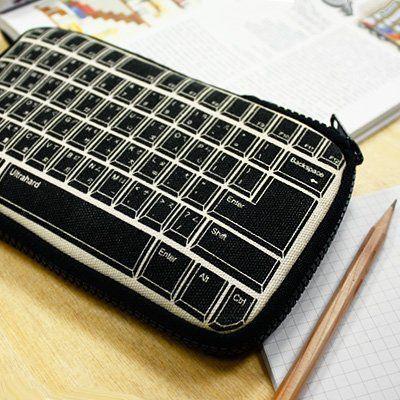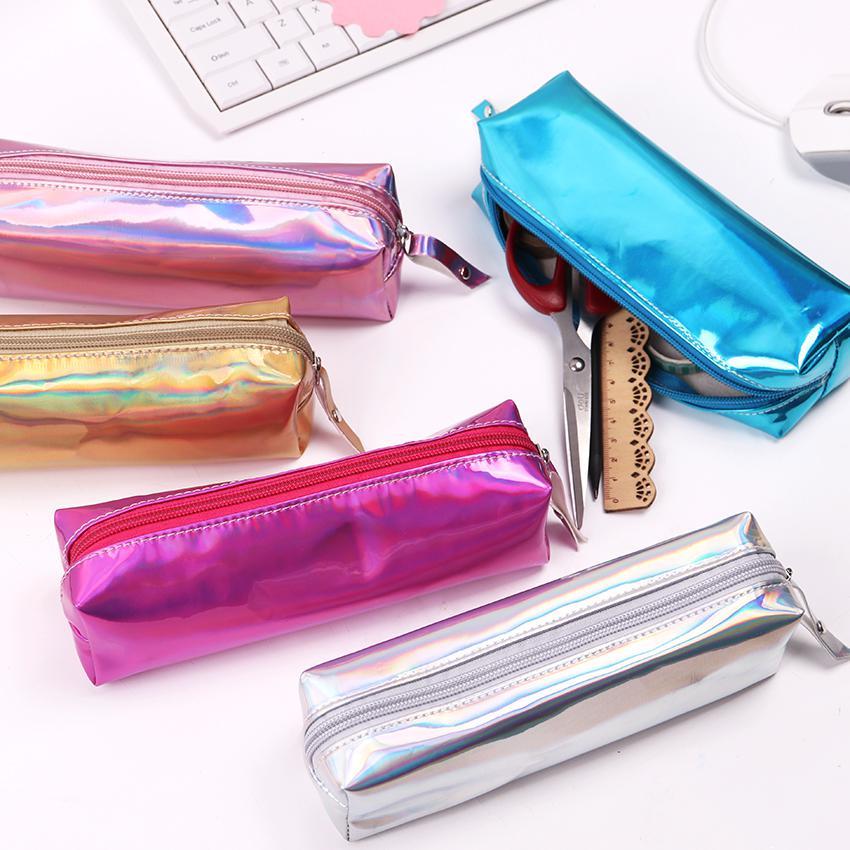The first image is the image on the left, the second image is the image on the right. Assess this claim about the two images: "At least one of the pouches contains an Eiffel tower object.". Correct or not? Answer yes or no. No. The first image is the image on the left, the second image is the image on the right. Examine the images to the left and right. Is the description "At least one image shows an open zipper case with rounded corners and a polka-dotted black interior filled with supplies." accurate? Answer yes or no. No. 